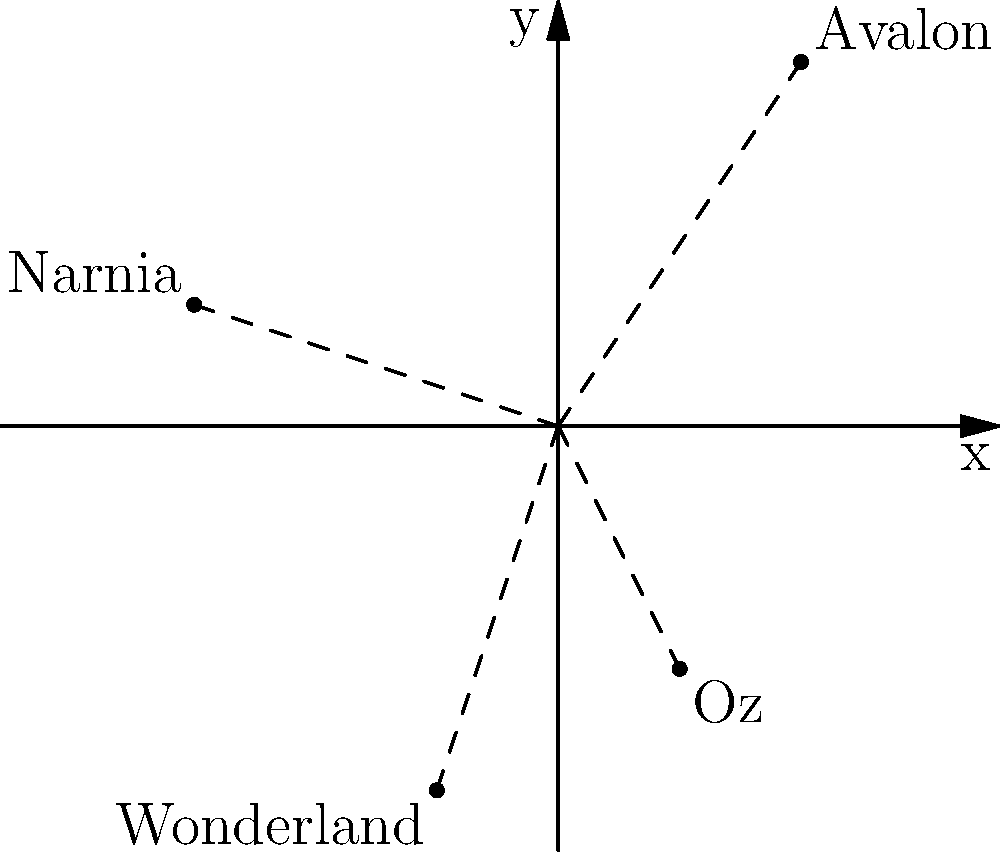In your latest fantasy novel, you've created a map of magical realms inspired by various literary works. The realms are plotted on a 2D coordinate system, where each unit represents 100 leagues. Given the coordinates of Avalon (2, 3), Narnia (-3, 1), Oz (1, -2), and Wonderland (-1, -3), what is the Manhattan distance between Avalon and Wonderland? Express your answer in leagues. To solve this problem, we'll follow these steps:

1. Recall that Manhattan distance is the sum of the absolute differences of the x and y coordinates.

2. Identify the coordinates:
   Avalon: (2, 3)
   Wonderland: (-1, -3)

3. Calculate the Manhattan distance:
   Manhattan distance = $|x_1 - x_2| + |y_1 - y_2|$
   Where $(x_1, y_1)$ is Avalon and $(x_2, y_2)$ is Wonderland

4. Plug in the values:
   $|2 - (-1)| + |3 - (-3)|$

5. Simplify:
   $|3| + |6|$

6. Calculate:
   $3 + 6 = 9$

7. Convert to leagues:
   Since each unit represents 100 leagues, multiply by 100:
   $9 \times 100 = 900$ leagues

Therefore, the Manhattan distance between Avalon and Wonderland is 900 leagues.
Answer: 900 leagues 